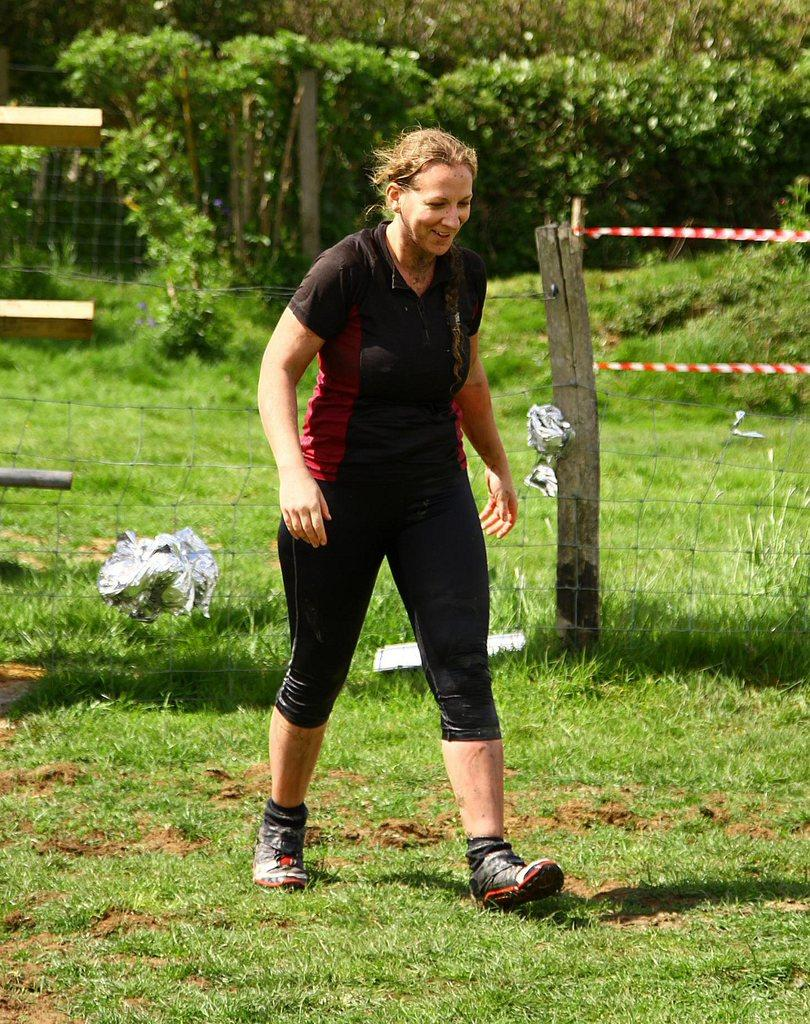What is the main subject of the image? There is a woman walking in the center of the image. What type of terrain is visible at the bottom of the image? There is grass at the bottom of the image. What can be seen in the background of the image? There are trees in the background of the image. What type of structure is present in the image? There is a fencing in the image. What type of match is the woman participating in the image? There is no match or competition present in the image; it simply shows a woman walking. What do the pigs say in the caption of the image? There is no caption or pigs present in the image. 